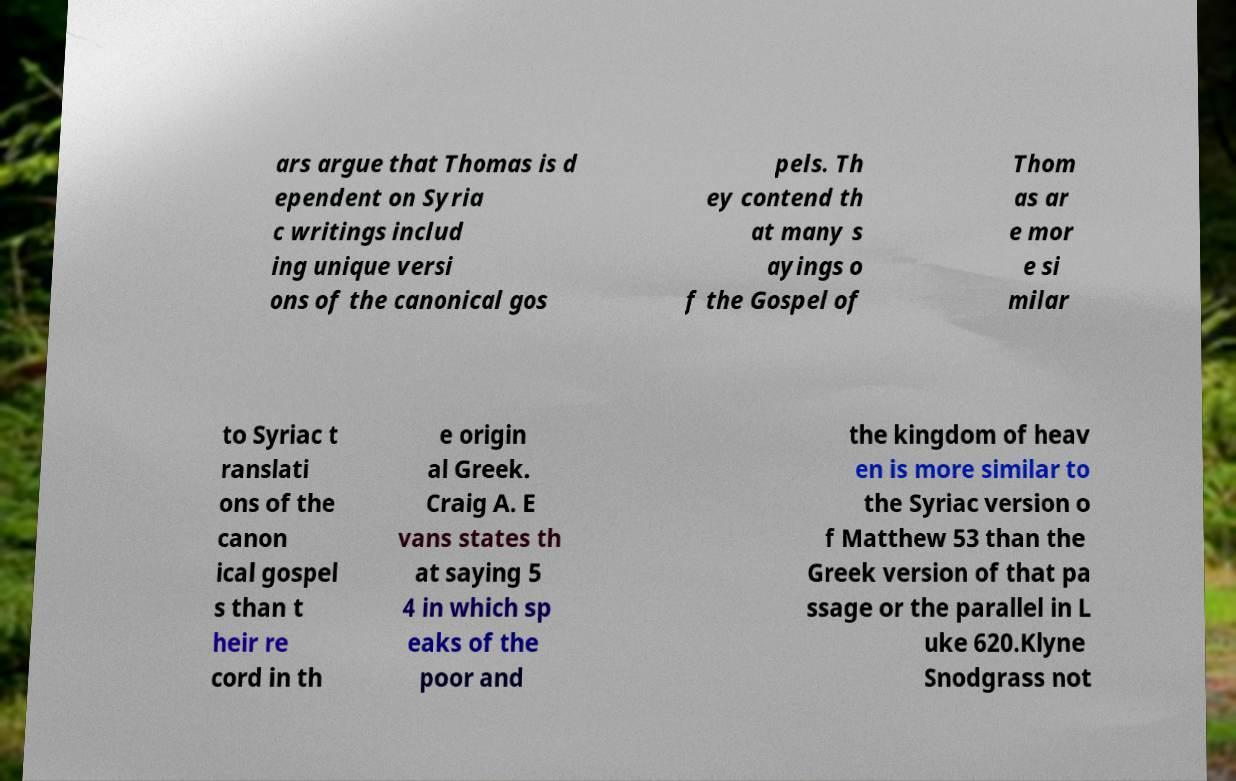There's text embedded in this image that I need extracted. Can you transcribe it verbatim? ars argue that Thomas is d ependent on Syria c writings includ ing unique versi ons of the canonical gos pels. Th ey contend th at many s ayings o f the Gospel of Thom as ar e mor e si milar to Syriac t ranslati ons of the canon ical gospel s than t heir re cord in th e origin al Greek. Craig A. E vans states th at saying 5 4 in which sp eaks of the poor and the kingdom of heav en is more similar to the Syriac version o f Matthew 53 than the Greek version of that pa ssage or the parallel in L uke 620.Klyne Snodgrass not 